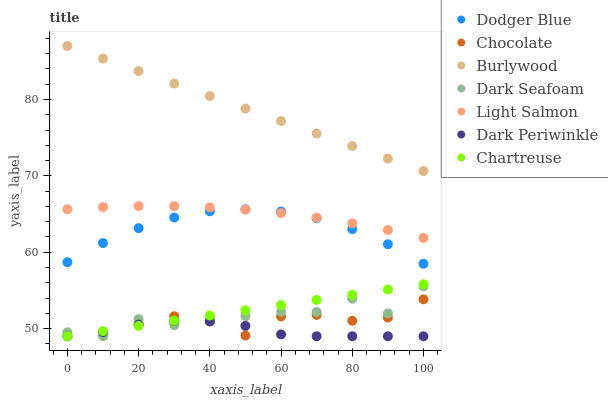Does Dark Periwinkle have the minimum area under the curve?
Answer yes or no. Yes. Does Burlywood have the maximum area under the curve?
Answer yes or no. Yes. Does Chartreuse have the minimum area under the curve?
Answer yes or no. No. Does Chartreuse have the maximum area under the curve?
Answer yes or no. No. Is Chartreuse the smoothest?
Answer yes or no. Yes. Is Dark Seafoam the roughest?
Answer yes or no. Yes. Is Burlywood the smoothest?
Answer yes or no. No. Is Burlywood the roughest?
Answer yes or no. No. Does Chartreuse have the lowest value?
Answer yes or no. Yes. Does Burlywood have the lowest value?
Answer yes or no. No. Does Burlywood have the highest value?
Answer yes or no. Yes. Does Chartreuse have the highest value?
Answer yes or no. No. Is Dodger Blue less than Burlywood?
Answer yes or no. Yes. Is Dodger Blue greater than Dark Seafoam?
Answer yes or no. Yes. Does Chartreuse intersect Dark Periwinkle?
Answer yes or no. Yes. Is Chartreuse less than Dark Periwinkle?
Answer yes or no. No. Is Chartreuse greater than Dark Periwinkle?
Answer yes or no. No. Does Dodger Blue intersect Burlywood?
Answer yes or no. No. 